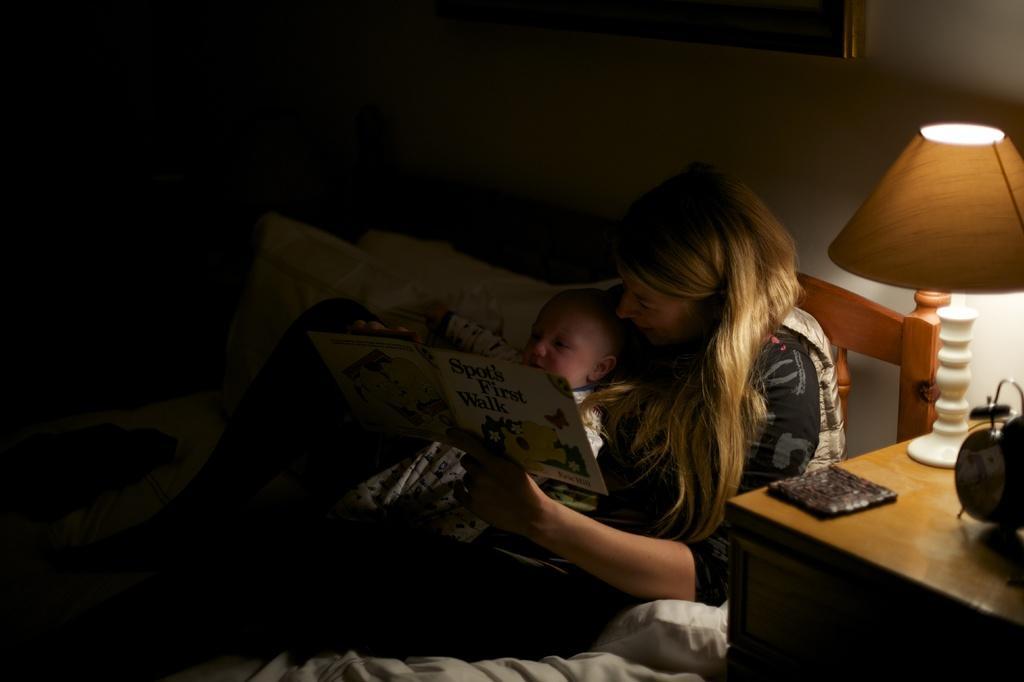Could you give a brief overview of what you see in this image? This picture shows a woman seated on the bed and holding a baby in her hands and seeing a book holding in her hand and we see a lamp on the table and 'clock on the side and we see a photo frame on the wall and pillows on the side 